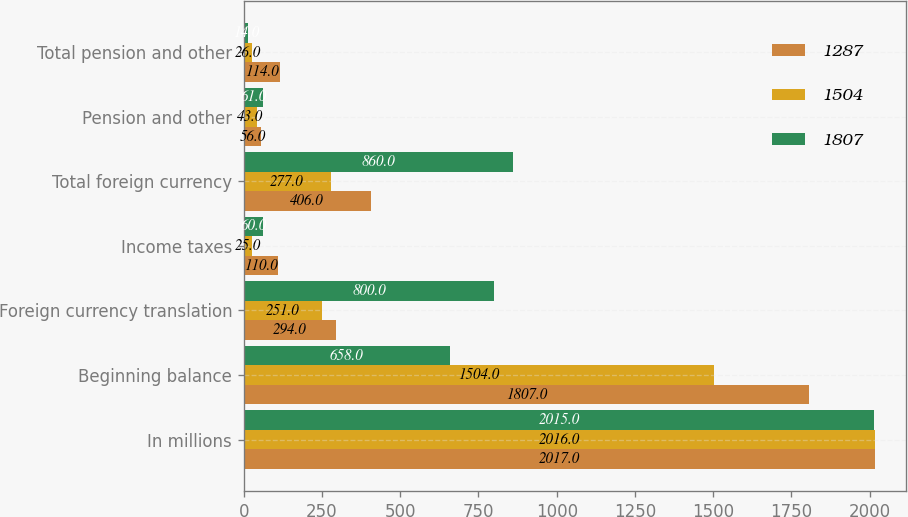<chart> <loc_0><loc_0><loc_500><loc_500><stacked_bar_chart><ecel><fcel>In millions<fcel>Beginning balance<fcel>Foreign currency translation<fcel>Income taxes<fcel>Total foreign currency<fcel>Pension and other<fcel>Total pension and other<nl><fcel>1287<fcel>2017<fcel>1807<fcel>294<fcel>110<fcel>406<fcel>56<fcel>114<nl><fcel>1504<fcel>2016<fcel>1504<fcel>251<fcel>25<fcel>277<fcel>43<fcel>26<nl><fcel>1807<fcel>2015<fcel>658<fcel>800<fcel>60<fcel>860<fcel>61<fcel>14<nl></chart> 